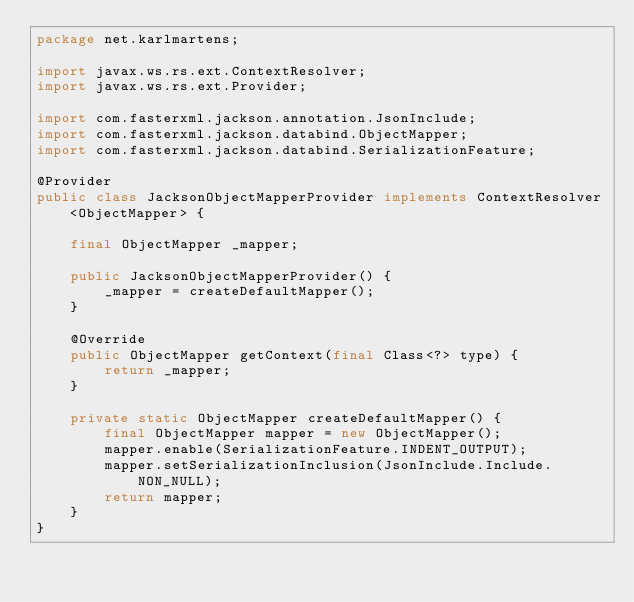Convert code to text. <code><loc_0><loc_0><loc_500><loc_500><_Java_>package net.karlmartens;

import javax.ws.rs.ext.ContextResolver;
import javax.ws.rs.ext.Provider;

import com.fasterxml.jackson.annotation.JsonInclude;
import com.fasterxml.jackson.databind.ObjectMapper;
import com.fasterxml.jackson.databind.SerializationFeature;

@Provider
public class JacksonObjectMapperProvider implements ContextResolver<ObjectMapper> {

    final ObjectMapper _mapper;

    public JacksonObjectMapperProvider() {
        _mapper = createDefaultMapper();
    }

    @Override
    public ObjectMapper getContext(final Class<?> type) {
        return _mapper;
    }

    private static ObjectMapper createDefaultMapper() {
        final ObjectMapper mapper = new ObjectMapper();
        mapper.enable(SerializationFeature.INDENT_OUTPUT);
        mapper.setSerializationInclusion(JsonInclude.Include.NON_NULL);
        return mapper;
    }
}</code> 